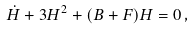Convert formula to latex. <formula><loc_0><loc_0><loc_500><loc_500>\dot { H } + 3 H ^ { 2 } + ( B + F ) H = 0 \, ,</formula> 